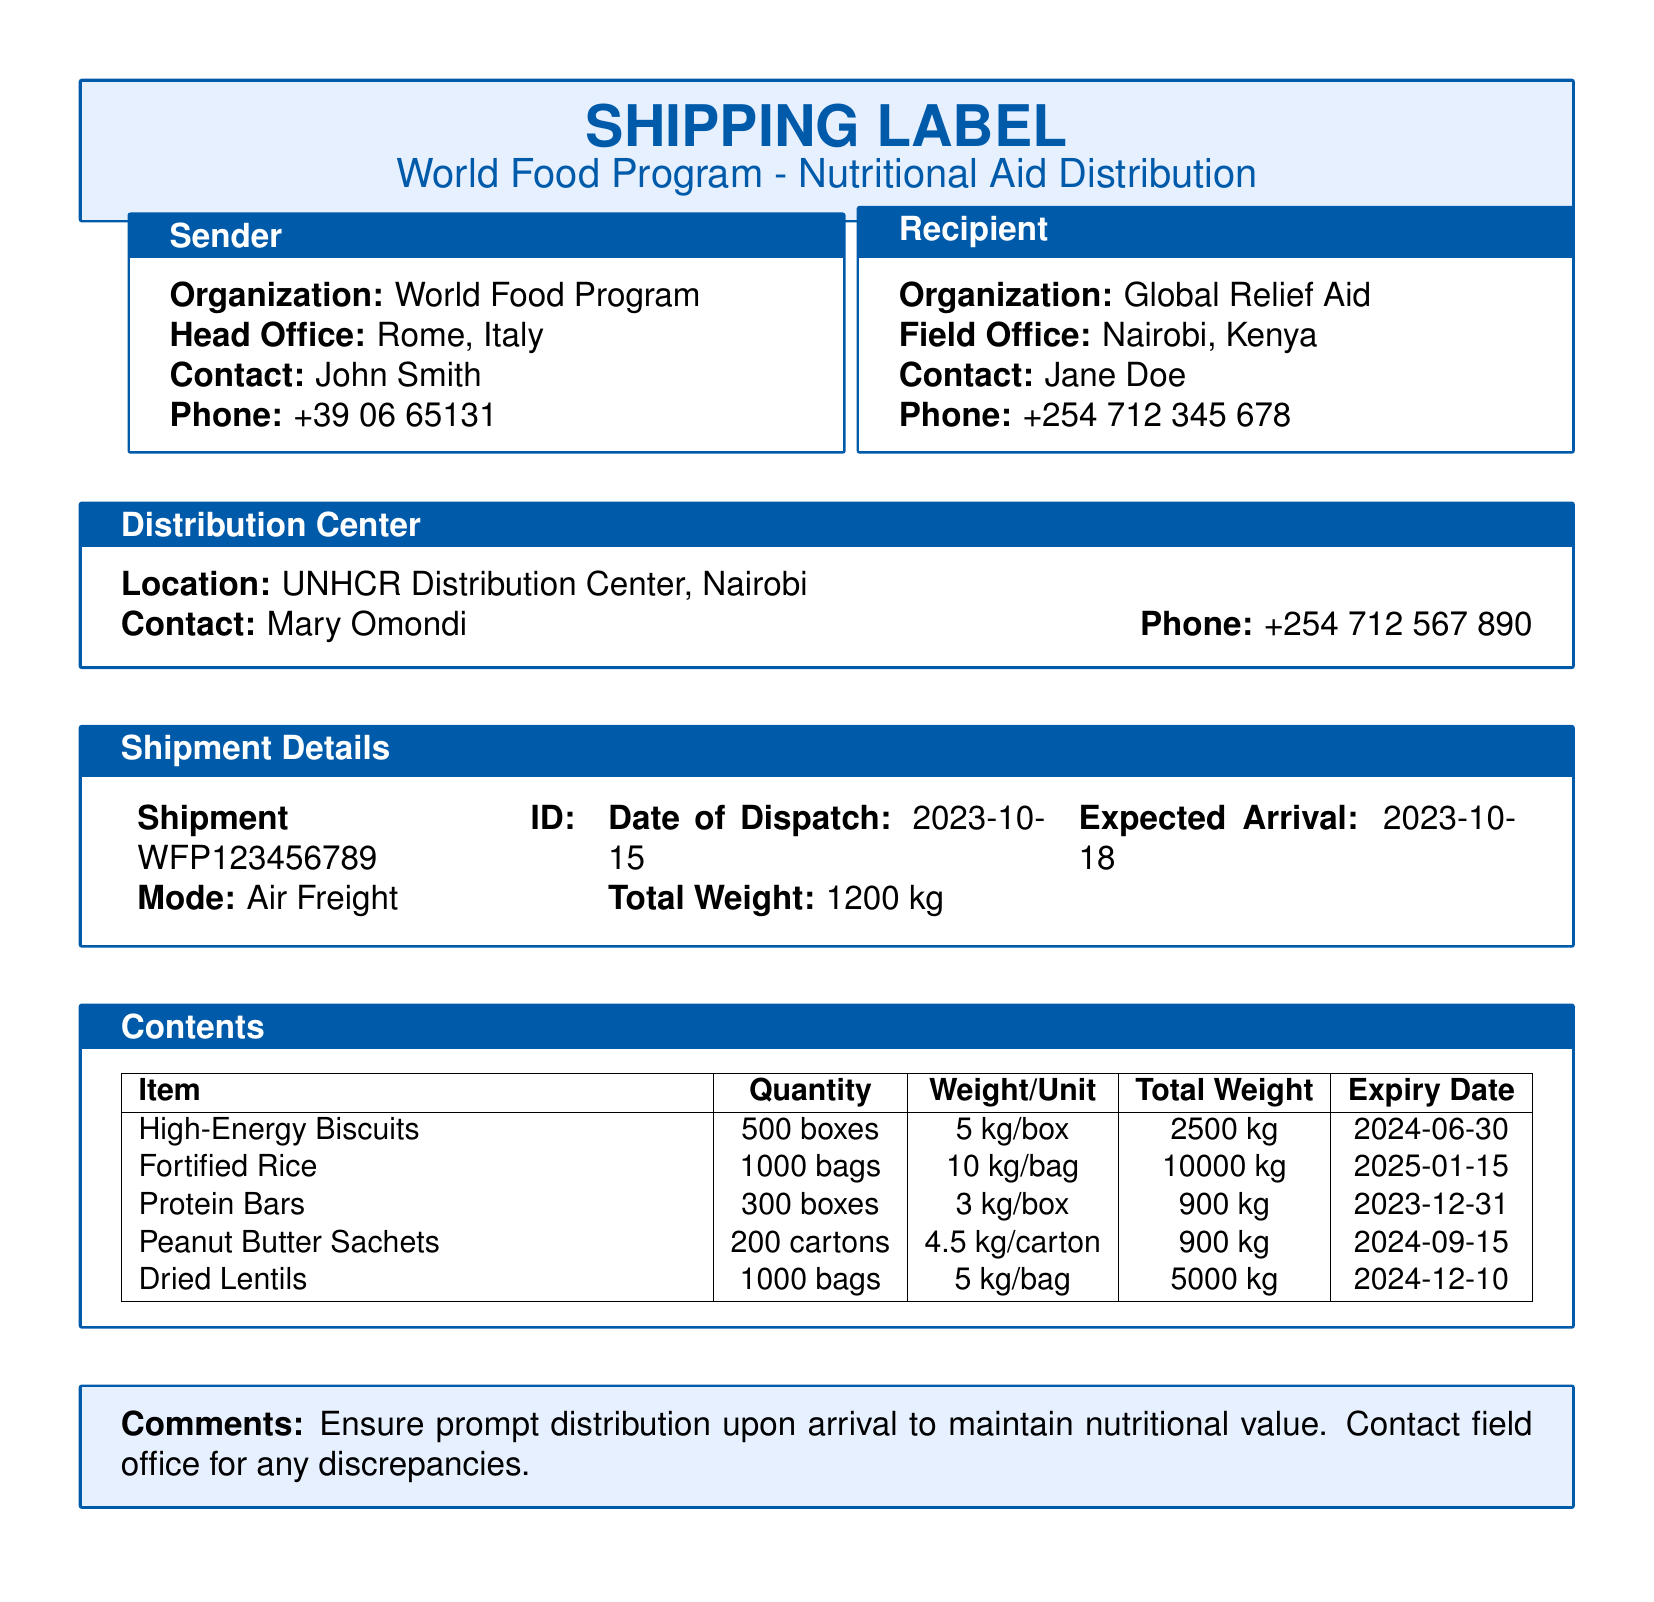what is the organization of the sender? The sender's organization is listed in the document as the World Food Program.
Answer: World Food Program what is the shipment ID? The shipment ID is a unique identifier mentioned in the Shipment Details section of the document.
Answer: WFP123456789 how many boxes of High-Energy Biscuits are there? The quantity of High-Energy Biscuits is specified in the Contents table of the document.
Answer: 500 boxes what is the total weight of Fortified Rice? The total weight of Fortified Rice can be calculated from the Contents table where the quantity and weight per unit are provided.
Answer: 10000 kg when is the expiry date for Protein Bars? The expiry date for Protein Bars is listed in the Contents table of the document.
Answer: 2023-12-31 who is the contact person at the recipient organization? The contact person for the recipient organization is mentioned in the Recipient section of the document.
Answer: Jane Doe what is the mode of transport for the shipment? The mode of transport can be found in the Shipment Details section of the document.
Answer: Air Freight how is the nutritional value to be maintained upon arrival? The Comments section provides guidance on how to maintain nutritional value after arrival.
Answer: Prompt distribution 